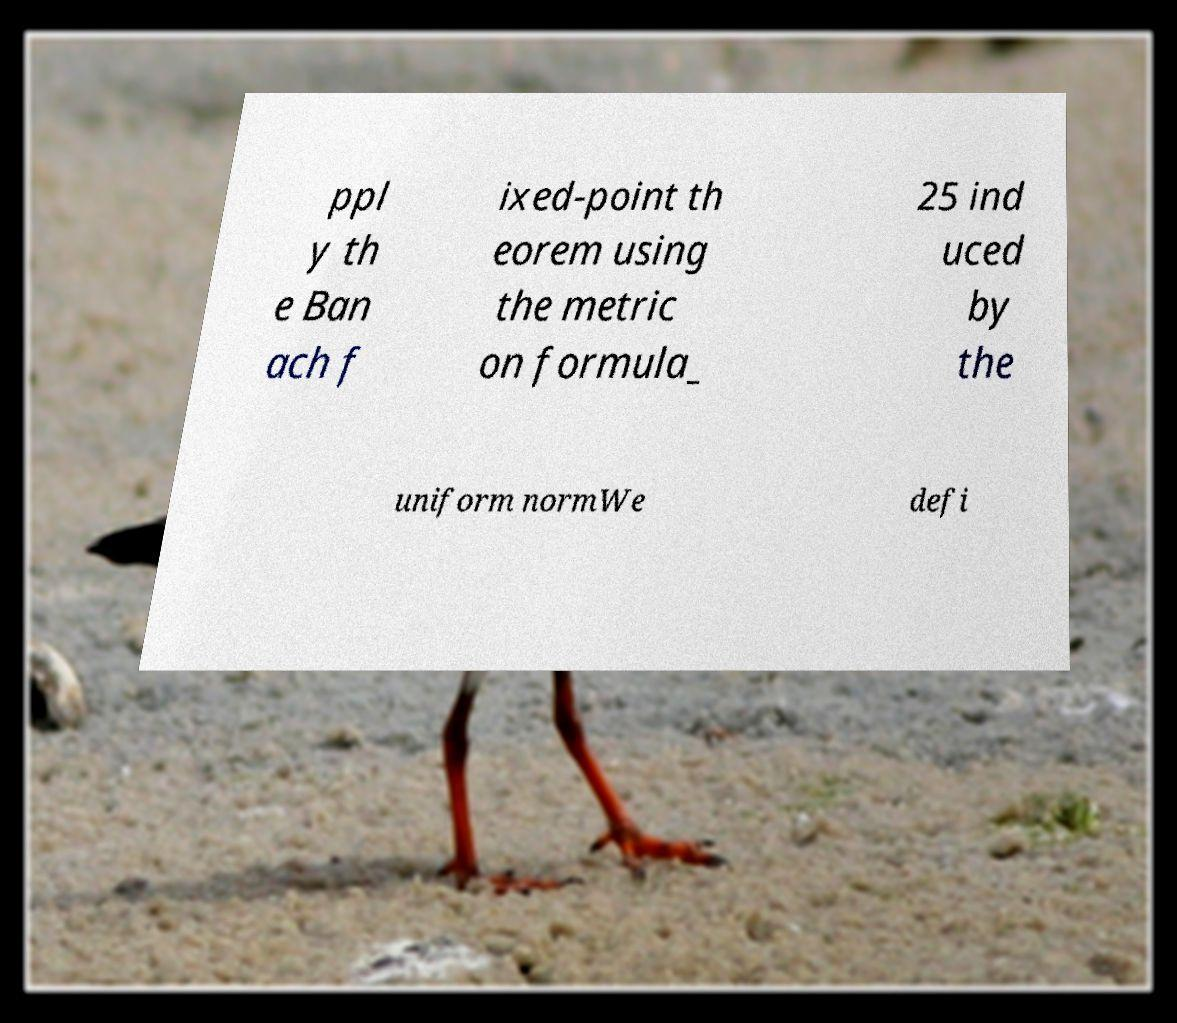Please read and relay the text visible in this image. What does it say? ppl y th e Ban ach f ixed-point th eorem using the metric on formula_ 25 ind uced by the uniform normWe defi 